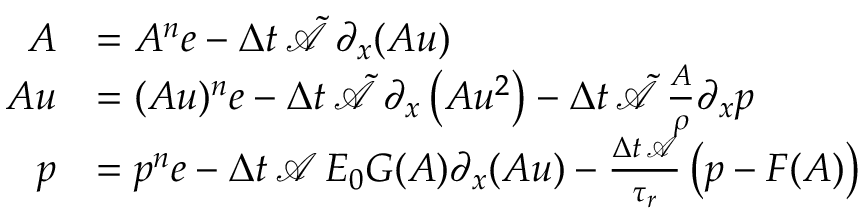Convert formula to latex. <formula><loc_0><loc_0><loc_500><loc_500>\begin{array} { r l } { A } & { = A ^ { n } e - \Delta t \, \tilde { \mathcal { A } } \, \partial _ { x } ( A u ) } \\ { A u } & { = ( A u ) ^ { n } e - \Delta t \, \tilde { \mathcal { A } } \, \partial _ { x } \left ( A u ^ { 2 } \right ) - \Delta t \, \tilde { \mathcal { A } } \, \frac { A } { \rho } \partial _ { x } p } \\ { p } & { = p ^ { n } e - \Delta t \, \mathcal { A } \, E _ { 0 } G ( A ) \partial _ { x } ( A u ) - \frac { \Delta t \, \mathcal { A } } { \tau _ { r } } \left ( p - F ( A ) \right ) } \end{array}</formula> 